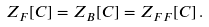Convert formula to latex. <formula><loc_0><loc_0><loc_500><loc_500>Z _ { F } [ C ] = Z _ { B } [ C ] = Z _ { F F } [ C ] \, .</formula> 